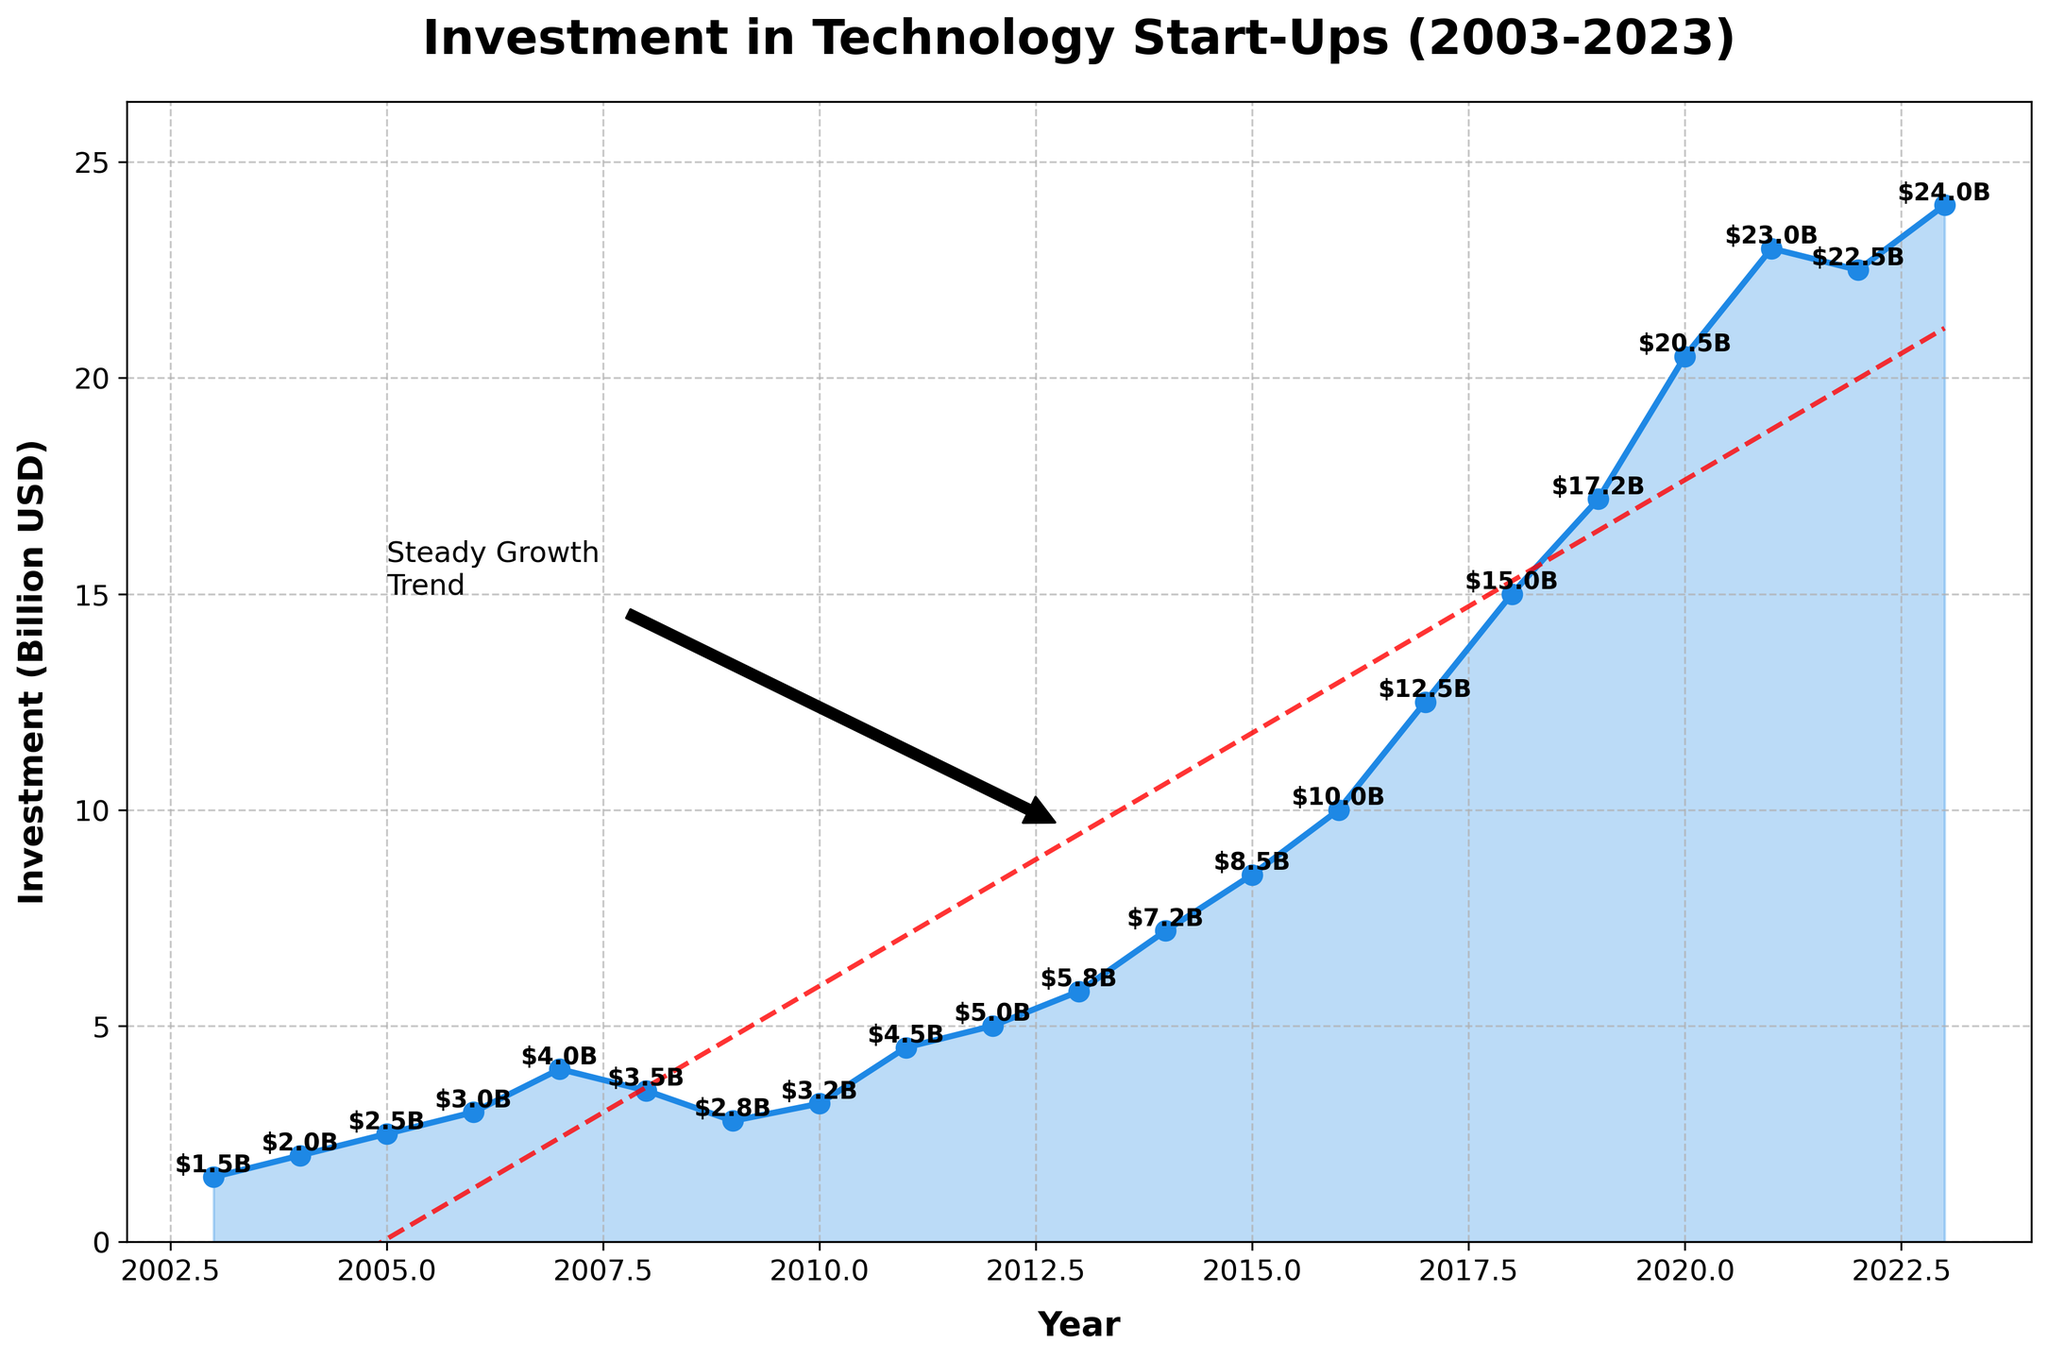What is the title of the plot? The title of the plot is typically printed at the top center of the figure. In this case, it is indicated as "Investment in Technology Start-Ups (2003-2023)".
Answer: Investment in Technology Start-Ups (2003-2023) What does the x-axis represent? The x-axis represents the years from 2003 to 2023. This is usually shown at the bottom of the plot.
Answer: Year What does the y-axis represent? The y-axis represents the investment in technology start-ups in billion USD, as shown on the left side of the plot.
Answer: Investment (Billion USD) How much was invested in technology start-ups in 2010? Locate the year 2010 on the x-axis and then find the corresponding value on the y-axis. The plot indicates an investment of $3.2 billion.
Answer: $3.2 billion In which year was the investment at its lowest? Find the lowest point on the plot and trace it back to the corresponding year on the x-axis. The lowest investment is $1.5 billion in the year 2003.
Answer: 2003 What is the trend line equation, and what does it indicate about the overall trend? The trend line equation is typically provided as a red dashed line. Based on the plot, it appears linear, suggesting a steady year-over-year growth in investments in tech start-ups. The exact equation is not provided in the figure, but the trend indicates consistent growth over time.
Answer: Linear trend, steady growth What is the total investment over the 20-year period? Sum the investment values for each year from 2003 to 2023. Adding all the investments: $1.5 + 2.0 + 2.5 + 3.0 + 4.0 + 3.5 + 2.8 + 3.2 + 4.5 + 5.0 + 5.8 + 7.2 + 8.5 + 10.0 + 12.5 + 15.0 + 17.2 + 20.5 + 23.0 + 22.5 + 24.0 = $172.2 billion.
Answer: $172.2 billion Which year saw the highest investment and what was the amount? Identify the highest peak on the plot and refer to the corresponding year on the x-axis and its value on the y-axis. The highest investment was in 2023 with $24.0 billion.
Answer: 2023, $24.0 billion What is the average annual investment over the time period? Calculate the average by dividing the total investment by the number of years. The total investment over 21 years is $172.2 billion, so the average annual investment is $172.2 billion / 21 ≈ $8.2 billion.
Answer: $8.2 billion Compare the investment in 2016 and 2020. Which year had higher investment and by how much? Locate 2016 and 2020 on the x-axis, then find their corresponding values on the y-axis. In 2016, the investment was $10.0 billion, and in 2020, it was $20.5 billion. The difference is $20.5 billion - $10.0 billion = $10.5 billion. 2020 had a higher investment by $10.5 billion.
Answer: 2020, $10.5 billion How did the investments change from 2019 to 2021? Locate 2019, 2020, and 2021 on the x-axis and find their corresponding y-axis values: $17.2 billion in 2019, $20.5 billion in 2020, and $23.0 billion in 2021. The change from 2019 to 2020 is $20.5 billion - $17.2 billion = $3.3 billion increase. From 2020 to 2021, it increased by $23.0 billion - $20.5 billion = $2.5 billion.
Answer: Steady increase, $3.3 billion and $2.5 billion 